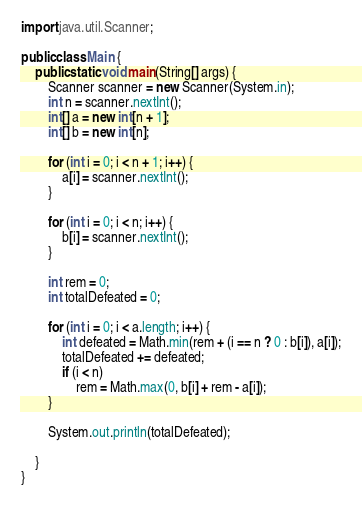Convert code to text. <code><loc_0><loc_0><loc_500><loc_500><_Java_>
import java.util.Scanner;

public class Main {
    public static void main(String[] args) {
        Scanner scanner = new Scanner(System.in);
        int n = scanner.nextInt();
        int[] a = new int[n + 1];
        int[] b = new int[n];

        for (int i = 0; i < n + 1; i++) {
            a[i] = scanner.nextInt();
        }

        for (int i = 0; i < n; i++) {
            b[i] = scanner.nextInt();
        }

        int rem = 0;
        int totalDefeated = 0;

        for (int i = 0; i < a.length; i++) {
            int defeated = Math.min(rem + (i == n ? 0 : b[i]), a[i]);
            totalDefeated += defeated;
            if (i < n)
                rem = Math.max(0, b[i] + rem - a[i]);
        }

        System.out.println(totalDefeated);

    }
}
</code> 